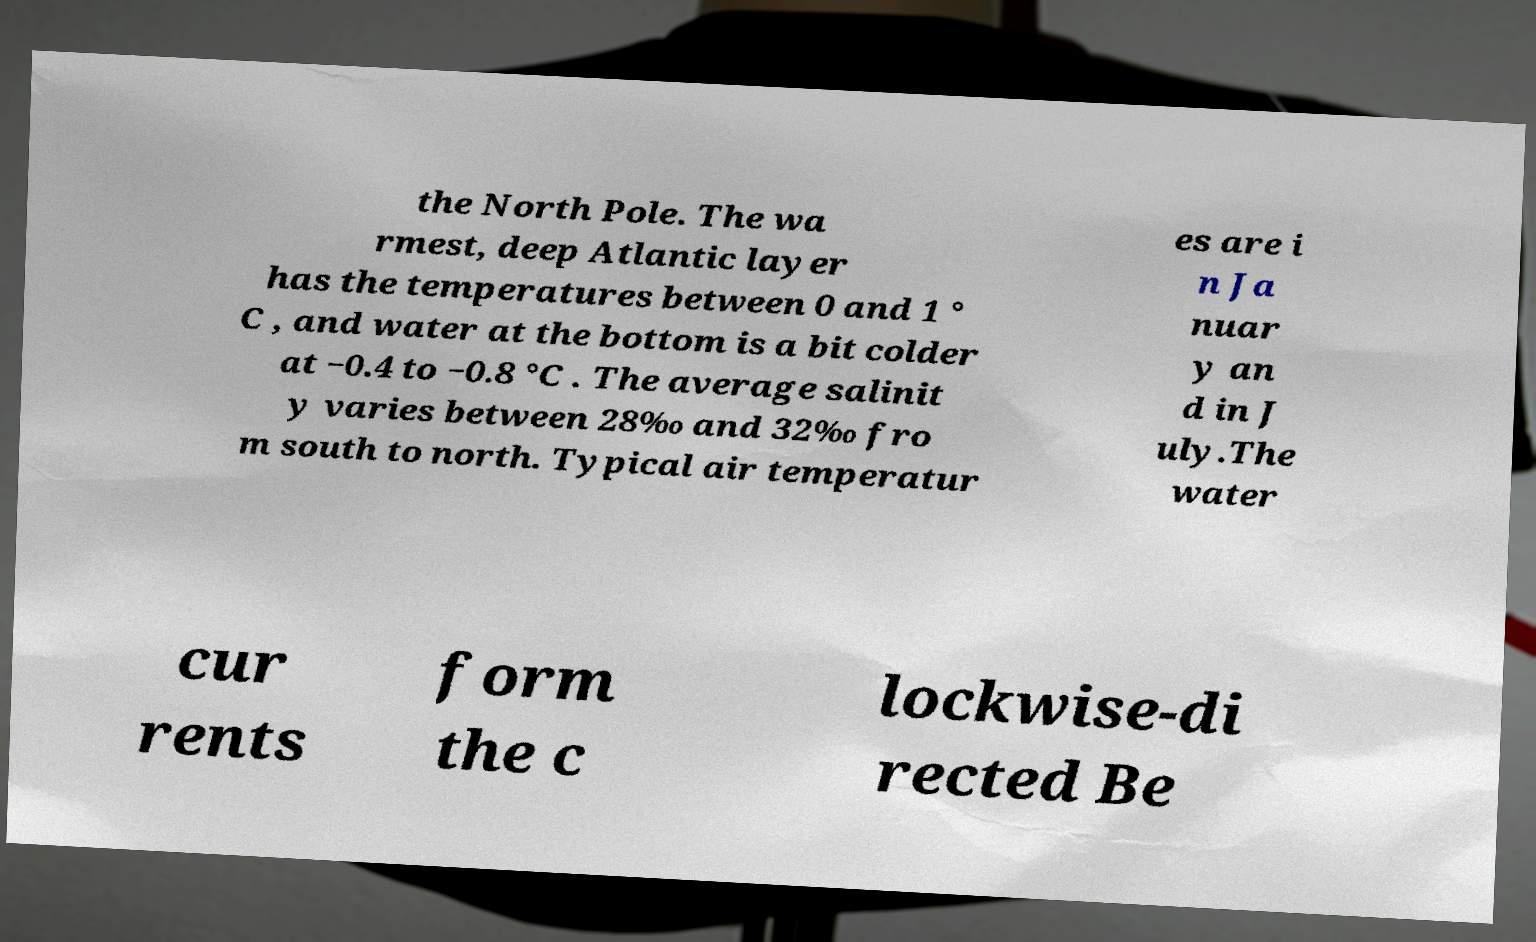What messages or text are displayed in this image? I need them in a readable, typed format. the North Pole. The wa rmest, deep Atlantic layer has the temperatures between 0 and 1 ° C , and water at the bottom is a bit colder at −0.4 to −0.8 °C . The average salinit y varies between 28‰ and 32‰ fro m south to north. Typical air temperatur es are i n Ja nuar y an d in J uly.The water cur rents form the c lockwise-di rected Be 